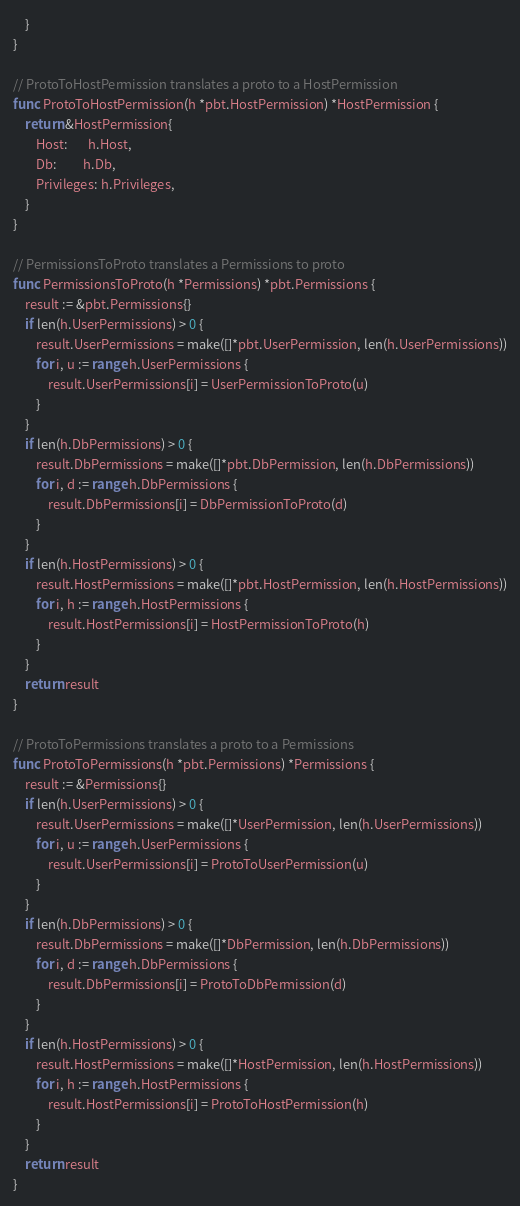Convert code to text. <code><loc_0><loc_0><loc_500><loc_500><_Go_>	}
}

// ProtoToHostPermission translates a proto to a HostPermission
func ProtoToHostPermission(h *pbt.HostPermission) *HostPermission {
	return &HostPermission{
		Host:       h.Host,
		Db:         h.Db,
		Privileges: h.Privileges,
	}
}

// PermissionsToProto translates a Permissions to proto
func PermissionsToProto(h *Permissions) *pbt.Permissions {
	result := &pbt.Permissions{}
	if len(h.UserPermissions) > 0 {
		result.UserPermissions = make([]*pbt.UserPermission, len(h.UserPermissions))
		for i, u := range h.UserPermissions {
			result.UserPermissions[i] = UserPermissionToProto(u)
		}
	}
	if len(h.DbPermissions) > 0 {
		result.DbPermissions = make([]*pbt.DbPermission, len(h.DbPermissions))
		for i, d := range h.DbPermissions {
			result.DbPermissions[i] = DbPermissionToProto(d)
		}
	}
	if len(h.HostPermissions) > 0 {
		result.HostPermissions = make([]*pbt.HostPermission, len(h.HostPermissions))
		for i, h := range h.HostPermissions {
			result.HostPermissions[i] = HostPermissionToProto(h)
		}
	}
	return result
}

// ProtoToPermissions translates a proto to a Permissions
func ProtoToPermissions(h *pbt.Permissions) *Permissions {
	result := &Permissions{}
	if len(h.UserPermissions) > 0 {
		result.UserPermissions = make([]*UserPermission, len(h.UserPermissions))
		for i, u := range h.UserPermissions {
			result.UserPermissions[i] = ProtoToUserPermission(u)
		}
	}
	if len(h.DbPermissions) > 0 {
		result.DbPermissions = make([]*DbPermission, len(h.DbPermissions))
		for i, d := range h.DbPermissions {
			result.DbPermissions[i] = ProtoToDbPermission(d)
		}
	}
	if len(h.HostPermissions) > 0 {
		result.HostPermissions = make([]*HostPermission, len(h.HostPermissions))
		for i, h := range h.HostPermissions {
			result.HostPermissions[i] = ProtoToHostPermission(h)
		}
	}
	return result
}
</code> 